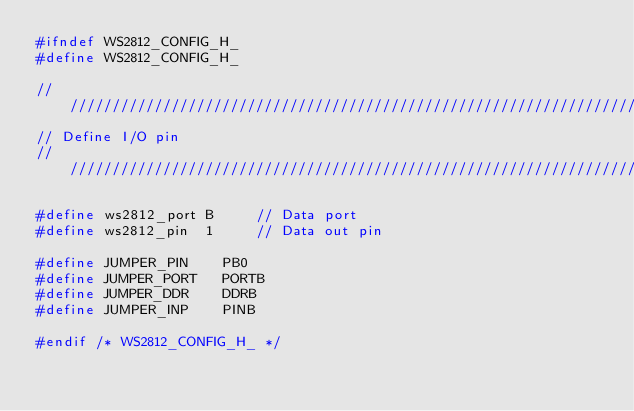Convert code to text. <code><loc_0><loc_0><loc_500><loc_500><_C_>#ifndef WS2812_CONFIG_H_
#define WS2812_CONFIG_H_

///////////////////////////////////////////////////////////////////////
// Define I/O pin
///////////////////////////////////////////////////////////////////////

#define ws2812_port B     // Data port 
#define ws2812_pin  1     // Data out pin

#define JUMPER_PIN    PB0
#define JUMPER_PORT   PORTB 
#define JUMPER_DDR    DDRB 
#define JUMPER_INP    PINB 

#endif /* WS2812_CONFIG_H_ */</code> 